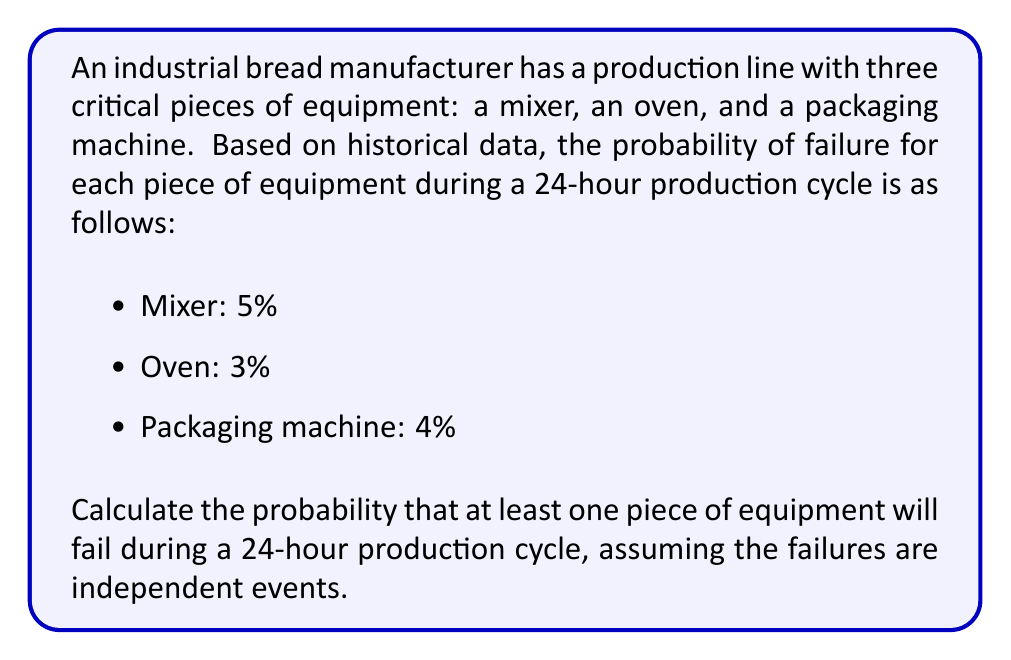Give your solution to this math problem. To solve this problem, we'll use the complement rule of probability. Instead of calculating the probability of at least one failure directly, we'll calculate the probability of no failures and subtract it from 1.

Let's break it down step by step:

1. Calculate the probability of no failure for each piece of equipment:
   - Mixer: $P(\text{no failure}) = 1 - 0.05 = 0.95$
   - Oven: $P(\text{no failure}) = 1 - 0.03 = 0.97$
   - Packaging machine: $P(\text{no failure}) = 1 - 0.04 = 0.96$

2. Since the failures are independent events, the probability of no failures in any of the equipment is the product of their individual probabilities of no failure:

   $$P(\text{no failures}) = 0.95 \times 0.97 \times 0.96 = 0.8836$$

3. Now, we can use the complement rule to find the probability of at least one failure:

   $$P(\text{at least one failure}) = 1 - P(\text{no failures})$$
   $$P(\text{at least one failure}) = 1 - 0.8836 = 0.1164$$

4. Convert the result to a percentage:

   $$0.1164 \times 100\% = 11.64\%$$

Therefore, the probability that at least one piece of equipment will fail during a 24-hour production cycle is approximately 11.64%.
Answer: 11.64% 